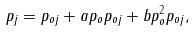Convert formula to latex. <formula><loc_0><loc_0><loc_500><loc_500>p _ { j } = p _ { o j } + a p _ { o } p _ { o j } + b p _ { o } ^ { 2 } p _ { o j } ,</formula> 